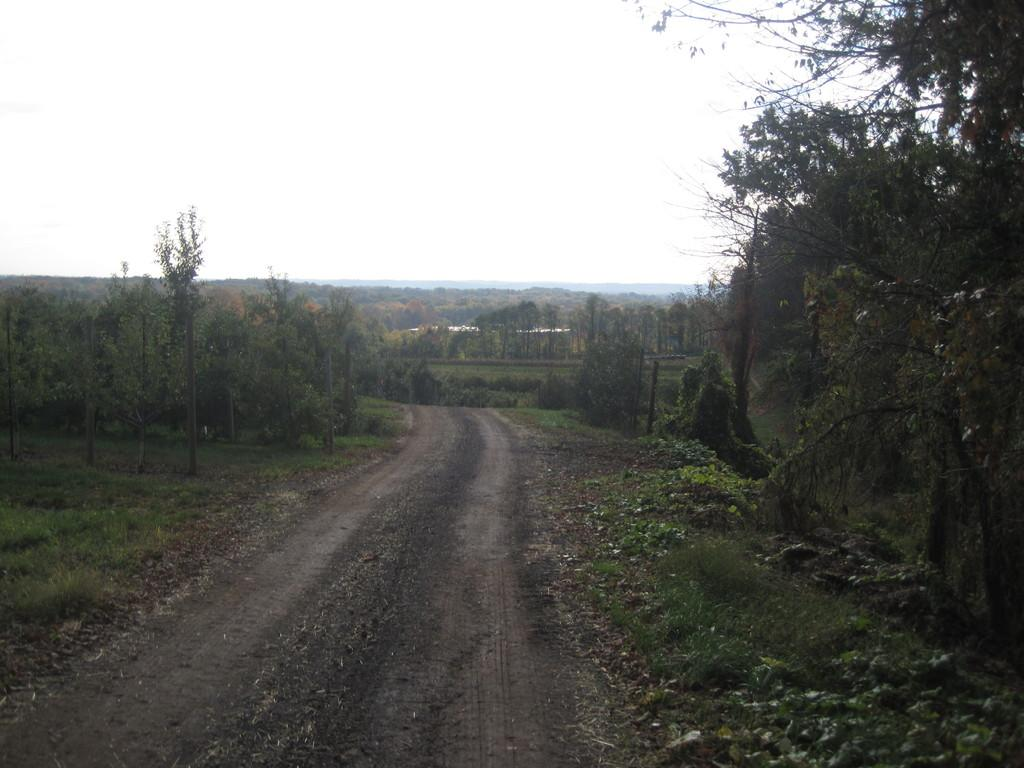What type of road is visible in the image? There is a mud road in the image. What can be seen on the left side of the image? There are trees on the left side of the image. What can be seen on the right side of the image? There are trees on the right side of the image. What is visible in the background of the image? The sky is visible in the background of the image. How would you describe the weather based on the sky in the image? The sky appears to be clear, suggesting good weather. Where is the notebook placed in the image? There is no notebook present in the image. Is the pig sleeping on the mud road in the image? There is no pig present in the image, so it cannot be sleeping on the mud road. 